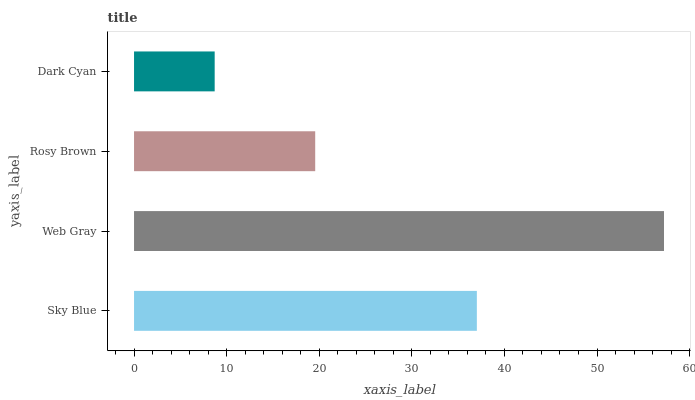Is Dark Cyan the minimum?
Answer yes or no. Yes. Is Web Gray the maximum?
Answer yes or no. Yes. Is Rosy Brown the minimum?
Answer yes or no. No. Is Rosy Brown the maximum?
Answer yes or no. No. Is Web Gray greater than Rosy Brown?
Answer yes or no. Yes. Is Rosy Brown less than Web Gray?
Answer yes or no. Yes. Is Rosy Brown greater than Web Gray?
Answer yes or no. No. Is Web Gray less than Rosy Brown?
Answer yes or no. No. Is Sky Blue the high median?
Answer yes or no. Yes. Is Rosy Brown the low median?
Answer yes or no. Yes. Is Rosy Brown the high median?
Answer yes or no. No. Is Dark Cyan the low median?
Answer yes or no. No. 